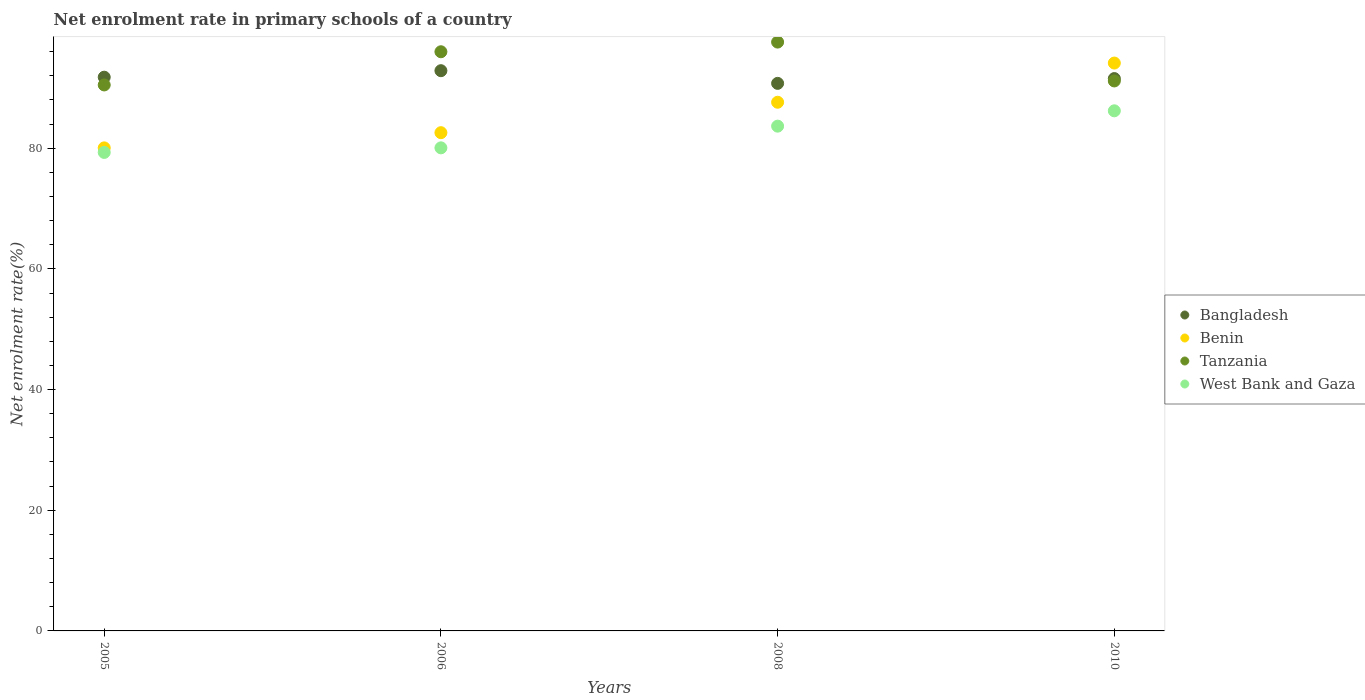How many different coloured dotlines are there?
Your response must be concise. 4. What is the net enrolment rate in primary schools in Tanzania in 2006?
Your response must be concise. 95.99. Across all years, what is the maximum net enrolment rate in primary schools in Bangladesh?
Give a very brief answer. 92.85. Across all years, what is the minimum net enrolment rate in primary schools in Tanzania?
Offer a very short reply. 90.49. What is the total net enrolment rate in primary schools in Tanzania in the graph?
Your response must be concise. 375.23. What is the difference between the net enrolment rate in primary schools in Bangladesh in 2006 and that in 2008?
Keep it short and to the point. 2.1. What is the difference between the net enrolment rate in primary schools in West Bank and Gaza in 2006 and the net enrolment rate in primary schools in Benin in 2005?
Your answer should be compact. 0.01. What is the average net enrolment rate in primary schools in Tanzania per year?
Provide a short and direct response. 93.81. In the year 2006, what is the difference between the net enrolment rate in primary schools in West Bank and Gaza and net enrolment rate in primary schools in Tanzania?
Ensure brevity in your answer.  -15.93. In how many years, is the net enrolment rate in primary schools in Tanzania greater than 40 %?
Your answer should be compact. 4. What is the ratio of the net enrolment rate in primary schools in Benin in 2005 to that in 2008?
Keep it short and to the point. 0.91. Is the net enrolment rate in primary schools in Benin in 2005 less than that in 2010?
Offer a very short reply. Yes. Is the difference between the net enrolment rate in primary schools in West Bank and Gaza in 2005 and 2006 greater than the difference between the net enrolment rate in primary schools in Tanzania in 2005 and 2006?
Ensure brevity in your answer.  Yes. What is the difference between the highest and the second highest net enrolment rate in primary schools in Benin?
Give a very brief answer. 6.5. What is the difference between the highest and the lowest net enrolment rate in primary schools in West Bank and Gaza?
Offer a very short reply. 6.9. In how many years, is the net enrolment rate in primary schools in West Bank and Gaza greater than the average net enrolment rate in primary schools in West Bank and Gaza taken over all years?
Your answer should be very brief. 2. Is the sum of the net enrolment rate in primary schools in Bangladesh in 2006 and 2008 greater than the maximum net enrolment rate in primary schools in Tanzania across all years?
Provide a succinct answer. Yes. How many dotlines are there?
Make the answer very short. 4. Are the values on the major ticks of Y-axis written in scientific E-notation?
Ensure brevity in your answer.  No. What is the title of the graph?
Offer a very short reply. Net enrolment rate in primary schools of a country. What is the label or title of the X-axis?
Your answer should be very brief. Years. What is the label or title of the Y-axis?
Provide a succinct answer. Net enrolment rate(%). What is the Net enrolment rate(%) of Bangladesh in 2005?
Keep it short and to the point. 91.78. What is the Net enrolment rate(%) in Benin in 2005?
Make the answer very short. 80.06. What is the Net enrolment rate(%) of Tanzania in 2005?
Your answer should be compact. 90.49. What is the Net enrolment rate(%) in West Bank and Gaza in 2005?
Your answer should be compact. 79.31. What is the Net enrolment rate(%) in Bangladesh in 2006?
Your response must be concise. 92.85. What is the Net enrolment rate(%) in Benin in 2006?
Offer a terse response. 82.58. What is the Net enrolment rate(%) in Tanzania in 2006?
Keep it short and to the point. 95.99. What is the Net enrolment rate(%) of West Bank and Gaza in 2006?
Give a very brief answer. 80.07. What is the Net enrolment rate(%) in Bangladesh in 2008?
Your answer should be very brief. 90.75. What is the Net enrolment rate(%) in Benin in 2008?
Give a very brief answer. 87.62. What is the Net enrolment rate(%) of Tanzania in 2008?
Provide a short and direct response. 97.59. What is the Net enrolment rate(%) in West Bank and Gaza in 2008?
Make the answer very short. 83.66. What is the Net enrolment rate(%) in Bangladesh in 2010?
Your answer should be compact. 91.55. What is the Net enrolment rate(%) of Benin in 2010?
Your response must be concise. 94.12. What is the Net enrolment rate(%) in Tanzania in 2010?
Offer a terse response. 91.15. What is the Net enrolment rate(%) of West Bank and Gaza in 2010?
Your answer should be compact. 86.2. Across all years, what is the maximum Net enrolment rate(%) in Bangladesh?
Give a very brief answer. 92.85. Across all years, what is the maximum Net enrolment rate(%) in Benin?
Provide a short and direct response. 94.12. Across all years, what is the maximum Net enrolment rate(%) of Tanzania?
Make the answer very short. 97.59. Across all years, what is the maximum Net enrolment rate(%) of West Bank and Gaza?
Your answer should be very brief. 86.2. Across all years, what is the minimum Net enrolment rate(%) of Bangladesh?
Offer a terse response. 90.75. Across all years, what is the minimum Net enrolment rate(%) of Benin?
Give a very brief answer. 80.06. Across all years, what is the minimum Net enrolment rate(%) in Tanzania?
Your answer should be compact. 90.49. Across all years, what is the minimum Net enrolment rate(%) of West Bank and Gaza?
Give a very brief answer. 79.31. What is the total Net enrolment rate(%) in Bangladesh in the graph?
Keep it short and to the point. 366.93. What is the total Net enrolment rate(%) of Benin in the graph?
Your answer should be very brief. 344.39. What is the total Net enrolment rate(%) of Tanzania in the graph?
Keep it short and to the point. 375.23. What is the total Net enrolment rate(%) of West Bank and Gaza in the graph?
Provide a short and direct response. 329.24. What is the difference between the Net enrolment rate(%) of Bangladesh in 2005 and that in 2006?
Provide a short and direct response. -1.08. What is the difference between the Net enrolment rate(%) in Benin in 2005 and that in 2006?
Offer a terse response. -2.52. What is the difference between the Net enrolment rate(%) of Tanzania in 2005 and that in 2006?
Provide a short and direct response. -5.5. What is the difference between the Net enrolment rate(%) of West Bank and Gaza in 2005 and that in 2006?
Offer a terse response. -0.76. What is the difference between the Net enrolment rate(%) of Benin in 2005 and that in 2008?
Provide a short and direct response. -7.56. What is the difference between the Net enrolment rate(%) in Tanzania in 2005 and that in 2008?
Your response must be concise. -7.1. What is the difference between the Net enrolment rate(%) in West Bank and Gaza in 2005 and that in 2008?
Provide a short and direct response. -4.36. What is the difference between the Net enrolment rate(%) of Bangladesh in 2005 and that in 2010?
Offer a very short reply. 0.23. What is the difference between the Net enrolment rate(%) of Benin in 2005 and that in 2010?
Offer a terse response. -14.06. What is the difference between the Net enrolment rate(%) of Tanzania in 2005 and that in 2010?
Your answer should be compact. -0.66. What is the difference between the Net enrolment rate(%) of West Bank and Gaza in 2005 and that in 2010?
Your answer should be very brief. -6.9. What is the difference between the Net enrolment rate(%) in Bangladesh in 2006 and that in 2008?
Give a very brief answer. 2.1. What is the difference between the Net enrolment rate(%) of Benin in 2006 and that in 2008?
Your response must be concise. -5.04. What is the difference between the Net enrolment rate(%) in Tanzania in 2006 and that in 2008?
Keep it short and to the point. -1.6. What is the difference between the Net enrolment rate(%) of West Bank and Gaza in 2006 and that in 2008?
Offer a terse response. -3.6. What is the difference between the Net enrolment rate(%) in Bangladesh in 2006 and that in 2010?
Your answer should be compact. 1.31. What is the difference between the Net enrolment rate(%) of Benin in 2006 and that in 2010?
Offer a very short reply. -11.54. What is the difference between the Net enrolment rate(%) in Tanzania in 2006 and that in 2010?
Offer a very short reply. 4.84. What is the difference between the Net enrolment rate(%) in West Bank and Gaza in 2006 and that in 2010?
Your answer should be compact. -6.14. What is the difference between the Net enrolment rate(%) in Bangladesh in 2008 and that in 2010?
Offer a terse response. -0.79. What is the difference between the Net enrolment rate(%) of Benin in 2008 and that in 2010?
Give a very brief answer. -6.5. What is the difference between the Net enrolment rate(%) in Tanzania in 2008 and that in 2010?
Your answer should be compact. 6.44. What is the difference between the Net enrolment rate(%) in West Bank and Gaza in 2008 and that in 2010?
Offer a terse response. -2.54. What is the difference between the Net enrolment rate(%) of Bangladesh in 2005 and the Net enrolment rate(%) of Benin in 2006?
Offer a terse response. 9.2. What is the difference between the Net enrolment rate(%) of Bangladesh in 2005 and the Net enrolment rate(%) of Tanzania in 2006?
Ensure brevity in your answer.  -4.22. What is the difference between the Net enrolment rate(%) in Bangladesh in 2005 and the Net enrolment rate(%) in West Bank and Gaza in 2006?
Your answer should be compact. 11.71. What is the difference between the Net enrolment rate(%) of Benin in 2005 and the Net enrolment rate(%) of Tanzania in 2006?
Give a very brief answer. -15.93. What is the difference between the Net enrolment rate(%) of Benin in 2005 and the Net enrolment rate(%) of West Bank and Gaza in 2006?
Make the answer very short. -0.01. What is the difference between the Net enrolment rate(%) in Tanzania in 2005 and the Net enrolment rate(%) in West Bank and Gaza in 2006?
Provide a short and direct response. 10.42. What is the difference between the Net enrolment rate(%) of Bangladesh in 2005 and the Net enrolment rate(%) of Benin in 2008?
Your answer should be compact. 4.15. What is the difference between the Net enrolment rate(%) of Bangladesh in 2005 and the Net enrolment rate(%) of Tanzania in 2008?
Your answer should be compact. -5.82. What is the difference between the Net enrolment rate(%) of Bangladesh in 2005 and the Net enrolment rate(%) of West Bank and Gaza in 2008?
Your response must be concise. 8.11. What is the difference between the Net enrolment rate(%) in Benin in 2005 and the Net enrolment rate(%) in Tanzania in 2008?
Provide a short and direct response. -17.53. What is the difference between the Net enrolment rate(%) in Benin in 2005 and the Net enrolment rate(%) in West Bank and Gaza in 2008?
Provide a succinct answer. -3.6. What is the difference between the Net enrolment rate(%) in Tanzania in 2005 and the Net enrolment rate(%) in West Bank and Gaza in 2008?
Ensure brevity in your answer.  6.83. What is the difference between the Net enrolment rate(%) of Bangladesh in 2005 and the Net enrolment rate(%) of Benin in 2010?
Provide a succinct answer. -2.34. What is the difference between the Net enrolment rate(%) of Bangladesh in 2005 and the Net enrolment rate(%) of Tanzania in 2010?
Provide a short and direct response. 0.62. What is the difference between the Net enrolment rate(%) of Bangladesh in 2005 and the Net enrolment rate(%) of West Bank and Gaza in 2010?
Keep it short and to the point. 5.57. What is the difference between the Net enrolment rate(%) of Benin in 2005 and the Net enrolment rate(%) of Tanzania in 2010?
Provide a short and direct response. -11.09. What is the difference between the Net enrolment rate(%) in Benin in 2005 and the Net enrolment rate(%) in West Bank and Gaza in 2010?
Offer a very short reply. -6.14. What is the difference between the Net enrolment rate(%) of Tanzania in 2005 and the Net enrolment rate(%) of West Bank and Gaza in 2010?
Your answer should be compact. 4.29. What is the difference between the Net enrolment rate(%) in Bangladesh in 2006 and the Net enrolment rate(%) in Benin in 2008?
Your answer should be very brief. 5.23. What is the difference between the Net enrolment rate(%) of Bangladesh in 2006 and the Net enrolment rate(%) of Tanzania in 2008?
Your answer should be compact. -4.74. What is the difference between the Net enrolment rate(%) in Bangladesh in 2006 and the Net enrolment rate(%) in West Bank and Gaza in 2008?
Offer a terse response. 9.19. What is the difference between the Net enrolment rate(%) in Benin in 2006 and the Net enrolment rate(%) in Tanzania in 2008?
Keep it short and to the point. -15.01. What is the difference between the Net enrolment rate(%) of Benin in 2006 and the Net enrolment rate(%) of West Bank and Gaza in 2008?
Provide a short and direct response. -1.08. What is the difference between the Net enrolment rate(%) in Tanzania in 2006 and the Net enrolment rate(%) in West Bank and Gaza in 2008?
Your answer should be compact. 12.33. What is the difference between the Net enrolment rate(%) in Bangladesh in 2006 and the Net enrolment rate(%) in Benin in 2010?
Your answer should be very brief. -1.27. What is the difference between the Net enrolment rate(%) in Bangladesh in 2006 and the Net enrolment rate(%) in Tanzania in 2010?
Offer a terse response. 1.7. What is the difference between the Net enrolment rate(%) of Bangladesh in 2006 and the Net enrolment rate(%) of West Bank and Gaza in 2010?
Offer a very short reply. 6.65. What is the difference between the Net enrolment rate(%) in Benin in 2006 and the Net enrolment rate(%) in Tanzania in 2010?
Provide a succinct answer. -8.57. What is the difference between the Net enrolment rate(%) in Benin in 2006 and the Net enrolment rate(%) in West Bank and Gaza in 2010?
Ensure brevity in your answer.  -3.62. What is the difference between the Net enrolment rate(%) of Tanzania in 2006 and the Net enrolment rate(%) of West Bank and Gaza in 2010?
Offer a very short reply. 9.79. What is the difference between the Net enrolment rate(%) in Bangladesh in 2008 and the Net enrolment rate(%) in Benin in 2010?
Your answer should be very brief. -3.37. What is the difference between the Net enrolment rate(%) of Bangladesh in 2008 and the Net enrolment rate(%) of Tanzania in 2010?
Ensure brevity in your answer.  -0.4. What is the difference between the Net enrolment rate(%) of Bangladesh in 2008 and the Net enrolment rate(%) of West Bank and Gaza in 2010?
Provide a short and direct response. 4.55. What is the difference between the Net enrolment rate(%) of Benin in 2008 and the Net enrolment rate(%) of Tanzania in 2010?
Provide a short and direct response. -3.53. What is the difference between the Net enrolment rate(%) in Benin in 2008 and the Net enrolment rate(%) in West Bank and Gaza in 2010?
Offer a very short reply. 1.42. What is the difference between the Net enrolment rate(%) in Tanzania in 2008 and the Net enrolment rate(%) in West Bank and Gaza in 2010?
Ensure brevity in your answer.  11.39. What is the average Net enrolment rate(%) in Bangladesh per year?
Offer a terse response. 91.73. What is the average Net enrolment rate(%) of Benin per year?
Offer a very short reply. 86.1. What is the average Net enrolment rate(%) in Tanzania per year?
Your answer should be compact. 93.81. What is the average Net enrolment rate(%) in West Bank and Gaza per year?
Keep it short and to the point. 82.31. In the year 2005, what is the difference between the Net enrolment rate(%) of Bangladesh and Net enrolment rate(%) of Benin?
Make the answer very short. 11.72. In the year 2005, what is the difference between the Net enrolment rate(%) of Bangladesh and Net enrolment rate(%) of Tanzania?
Offer a very short reply. 1.29. In the year 2005, what is the difference between the Net enrolment rate(%) in Bangladesh and Net enrolment rate(%) in West Bank and Gaza?
Your answer should be very brief. 12.47. In the year 2005, what is the difference between the Net enrolment rate(%) in Benin and Net enrolment rate(%) in Tanzania?
Offer a very short reply. -10.43. In the year 2005, what is the difference between the Net enrolment rate(%) of Benin and Net enrolment rate(%) of West Bank and Gaza?
Provide a succinct answer. 0.75. In the year 2005, what is the difference between the Net enrolment rate(%) of Tanzania and Net enrolment rate(%) of West Bank and Gaza?
Offer a very short reply. 11.18. In the year 2006, what is the difference between the Net enrolment rate(%) of Bangladesh and Net enrolment rate(%) of Benin?
Provide a succinct answer. 10.27. In the year 2006, what is the difference between the Net enrolment rate(%) in Bangladesh and Net enrolment rate(%) in Tanzania?
Make the answer very short. -3.14. In the year 2006, what is the difference between the Net enrolment rate(%) in Bangladesh and Net enrolment rate(%) in West Bank and Gaza?
Provide a short and direct response. 12.79. In the year 2006, what is the difference between the Net enrolment rate(%) of Benin and Net enrolment rate(%) of Tanzania?
Offer a very short reply. -13.41. In the year 2006, what is the difference between the Net enrolment rate(%) of Benin and Net enrolment rate(%) of West Bank and Gaza?
Offer a terse response. 2.51. In the year 2006, what is the difference between the Net enrolment rate(%) of Tanzania and Net enrolment rate(%) of West Bank and Gaza?
Provide a short and direct response. 15.93. In the year 2008, what is the difference between the Net enrolment rate(%) in Bangladesh and Net enrolment rate(%) in Benin?
Offer a terse response. 3.13. In the year 2008, what is the difference between the Net enrolment rate(%) of Bangladesh and Net enrolment rate(%) of Tanzania?
Offer a terse response. -6.84. In the year 2008, what is the difference between the Net enrolment rate(%) of Bangladesh and Net enrolment rate(%) of West Bank and Gaza?
Give a very brief answer. 7.09. In the year 2008, what is the difference between the Net enrolment rate(%) of Benin and Net enrolment rate(%) of Tanzania?
Ensure brevity in your answer.  -9.97. In the year 2008, what is the difference between the Net enrolment rate(%) in Benin and Net enrolment rate(%) in West Bank and Gaza?
Your response must be concise. 3.96. In the year 2008, what is the difference between the Net enrolment rate(%) in Tanzania and Net enrolment rate(%) in West Bank and Gaza?
Your answer should be very brief. 13.93. In the year 2010, what is the difference between the Net enrolment rate(%) in Bangladesh and Net enrolment rate(%) in Benin?
Offer a very short reply. -2.57. In the year 2010, what is the difference between the Net enrolment rate(%) in Bangladesh and Net enrolment rate(%) in Tanzania?
Provide a short and direct response. 0.39. In the year 2010, what is the difference between the Net enrolment rate(%) in Bangladesh and Net enrolment rate(%) in West Bank and Gaza?
Provide a short and direct response. 5.34. In the year 2010, what is the difference between the Net enrolment rate(%) of Benin and Net enrolment rate(%) of Tanzania?
Your response must be concise. 2.97. In the year 2010, what is the difference between the Net enrolment rate(%) in Benin and Net enrolment rate(%) in West Bank and Gaza?
Offer a terse response. 7.92. In the year 2010, what is the difference between the Net enrolment rate(%) in Tanzania and Net enrolment rate(%) in West Bank and Gaza?
Your response must be concise. 4.95. What is the ratio of the Net enrolment rate(%) in Bangladesh in 2005 to that in 2006?
Make the answer very short. 0.99. What is the ratio of the Net enrolment rate(%) in Benin in 2005 to that in 2006?
Offer a very short reply. 0.97. What is the ratio of the Net enrolment rate(%) of Tanzania in 2005 to that in 2006?
Offer a very short reply. 0.94. What is the ratio of the Net enrolment rate(%) in Bangladesh in 2005 to that in 2008?
Your answer should be very brief. 1.01. What is the ratio of the Net enrolment rate(%) of Benin in 2005 to that in 2008?
Your answer should be compact. 0.91. What is the ratio of the Net enrolment rate(%) of Tanzania in 2005 to that in 2008?
Keep it short and to the point. 0.93. What is the ratio of the Net enrolment rate(%) in West Bank and Gaza in 2005 to that in 2008?
Offer a very short reply. 0.95. What is the ratio of the Net enrolment rate(%) of Benin in 2005 to that in 2010?
Provide a short and direct response. 0.85. What is the ratio of the Net enrolment rate(%) in Tanzania in 2005 to that in 2010?
Provide a succinct answer. 0.99. What is the ratio of the Net enrolment rate(%) of West Bank and Gaza in 2005 to that in 2010?
Provide a succinct answer. 0.92. What is the ratio of the Net enrolment rate(%) in Bangladesh in 2006 to that in 2008?
Your response must be concise. 1.02. What is the ratio of the Net enrolment rate(%) in Benin in 2006 to that in 2008?
Ensure brevity in your answer.  0.94. What is the ratio of the Net enrolment rate(%) of Tanzania in 2006 to that in 2008?
Keep it short and to the point. 0.98. What is the ratio of the Net enrolment rate(%) in West Bank and Gaza in 2006 to that in 2008?
Your answer should be very brief. 0.96. What is the ratio of the Net enrolment rate(%) of Bangladesh in 2006 to that in 2010?
Offer a terse response. 1.01. What is the ratio of the Net enrolment rate(%) in Benin in 2006 to that in 2010?
Keep it short and to the point. 0.88. What is the ratio of the Net enrolment rate(%) of Tanzania in 2006 to that in 2010?
Ensure brevity in your answer.  1.05. What is the ratio of the Net enrolment rate(%) in West Bank and Gaza in 2006 to that in 2010?
Offer a terse response. 0.93. What is the ratio of the Net enrolment rate(%) in Bangladesh in 2008 to that in 2010?
Your response must be concise. 0.99. What is the ratio of the Net enrolment rate(%) of Tanzania in 2008 to that in 2010?
Your response must be concise. 1.07. What is the ratio of the Net enrolment rate(%) in West Bank and Gaza in 2008 to that in 2010?
Give a very brief answer. 0.97. What is the difference between the highest and the second highest Net enrolment rate(%) of Bangladesh?
Make the answer very short. 1.08. What is the difference between the highest and the second highest Net enrolment rate(%) in Benin?
Provide a short and direct response. 6.5. What is the difference between the highest and the second highest Net enrolment rate(%) in Tanzania?
Ensure brevity in your answer.  1.6. What is the difference between the highest and the second highest Net enrolment rate(%) of West Bank and Gaza?
Ensure brevity in your answer.  2.54. What is the difference between the highest and the lowest Net enrolment rate(%) in Bangladesh?
Offer a very short reply. 2.1. What is the difference between the highest and the lowest Net enrolment rate(%) in Benin?
Provide a succinct answer. 14.06. What is the difference between the highest and the lowest Net enrolment rate(%) in Tanzania?
Your answer should be very brief. 7.1. What is the difference between the highest and the lowest Net enrolment rate(%) in West Bank and Gaza?
Ensure brevity in your answer.  6.9. 